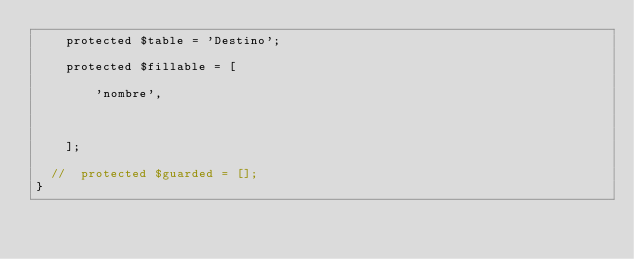Convert code to text. <code><loc_0><loc_0><loc_500><loc_500><_PHP_>    protected $table = 'Destino';

    protected $fillable = [

        'nombre',



    ];

  //  protected $guarded = [];
}
</code> 